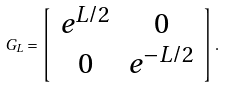<formula> <loc_0><loc_0><loc_500><loc_500>G _ { L } = \left [ \begin{array} { c c } e ^ { L / 2 } & 0 \\ 0 & e ^ { - L / 2 } \end{array} \right ] .</formula> 